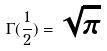Convert formula to latex. <formula><loc_0><loc_0><loc_500><loc_500>\Gamma ( \frac { 1 } { 2 } ) = \sqrt { \pi }</formula> 